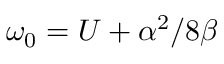<formula> <loc_0><loc_0><loc_500><loc_500>\omega _ { 0 } = U + \alpha ^ { 2 } / 8 \beta</formula> 